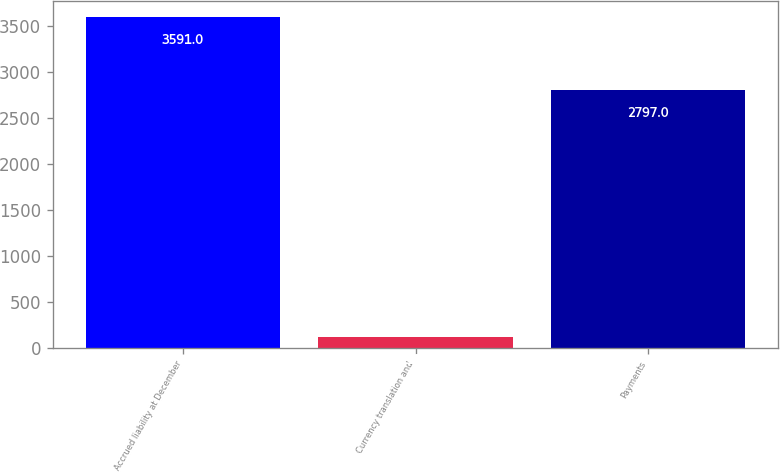Convert chart. <chart><loc_0><loc_0><loc_500><loc_500><bar_chart><fcel>Accrued liability at December<fcel>Currency translation and<fcel>Payments<nl><fcel>3591<fcel>113<fcel>2797<nl></chart> 